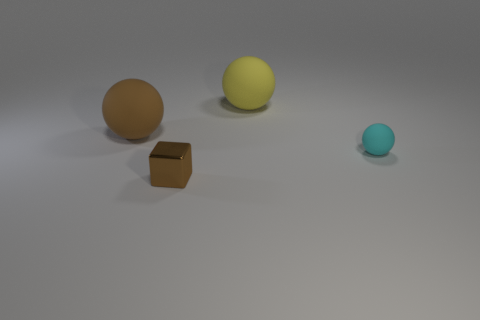Are there fewer cyan balls than tiny purple metal objects?
Your answer should be compact. No. The sphere that is both in front of the yellow rubber object and left of the cyan matte ball is made of what material?
Offer a very short reply. Rubber. Are there any yellow rubber objects in front of the object in front of the tiny cyan ball?
Offer a very short reply. No. What number of tiny things are the same color as the block?
Your answer should be very brief. 0. Does the yellow ball have the same material as the cyan thing?
Provide a short and direct response. Yes. There is a brown shiny cube; are there any yellow balls on the right side of it?
Your answer should be very brief. Yes. The brown object behind the cyan rubber sphere that is behind the tiny brown shiny thing is made of what material?
Give a very brief answer. Rubber. The brown rubber object that is the same shape as the yellow thing is what size?
Provide a short and direct response. Large. What color is the matte ball that is both in front of the yellow thing and behind the tiny cyan matte object?
Keep it short and to the point. Brown. There is a rubber object to the right of the yellow matte ball; does it have the same size as the large yellow sphere?
Your answer should be compact. No. 